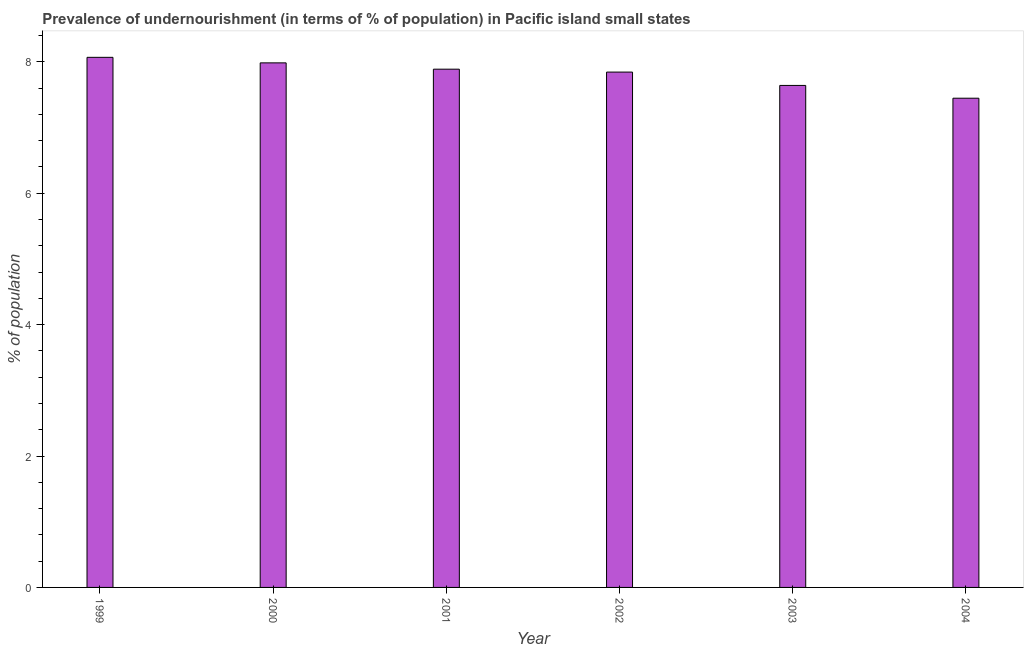Does the graph contain grids?
Your answer should be very brief. No. What is the title of the graph?
Your answer should be compact. Prevalence of undernourishment (in terms of % of population) in Pacific island small states. What is the label or title of the X-axis?
Your response must be concise. Year. What is the label or title of the Y-axis?
Keep it short and to the point. % of population. What is the percentage of undernourished population in 2004?
Offer a terse response. 7.45. Across all years, what is the maximum percentage of undernourished population?
Your response must be concise. 8.07. Across all years, what is the minimum percentage of undernourished population?
Give a very brief answer. 7.45. What is the sum of the percentage of undernourished population?
Your answer should be compact. 46.87. What is the difference between the percentage of undernourished population in 2002 and 2004?
Offer a very short reply. 0.4. What is the average percentage of undernourished population per year?
Provide a succinct answer. 7.81. What is the median percentage of undernourished population?
Your answer should be compact. 7.87. In how many years, is the percentage of undernourished population greater than 3.6 %?
Offer a terse response. 6. Do a majority of the years between 1999 and 2000 (inclusive) have percentage of undernourished population greater than 2.8 %?
Make the answer very short. Yes. Is the percentage of undernourished population in 1999 less than that in 2000?
Your answer should be compact. No. What is the difference between the highest and the second highest percentage of undernourished population?
Make the answer very short. 0.08. What is the difference between the highest and the lowest percentage of undernourished population?
Offer a very short reply. 0.62. How many bars are there?
Make the answer very short. 6. How many years are there in the graph?
Ensure brevity in your answer.  6. What is the difference between two consecutive major ticks on the Y-axis?
Your response must be concise. 2. What is the % of population of 1999?
Offer a terse response. 8.07. What is the % of population in 2000?
Provide a short and direct response. 7.98. What is the % of population in 2001?
Make the answer very short. 7.89. What is the % of population of 2002?
Your answer should be very brief. 7.84. What is the % of population of 2003?
Provide a succinct answer. 7.64. What is the % of population of 2004?
Provide a short and direct response. 7.45. What is the difference between the % of population in 1999 and 2000?
Offer a very short reply. 0.08. What is the difference between the % of population in 1999 and 2001?
Ensure brevity in your answer.  0.18. What is the difference between the % of population in 1999 and 2002?
Ensure brevity in your answer.  0.22. What is the difference between the % of population in 1999 and 2003?
Make the answer very short. 0.43. What is the difference between the % of population in 1999 and 2004?
Offer a terse response. 0.62. What is the difference between the % of population in 2000 and 2001?
Provide a succinct answer. 0.1. What is the difference between the % of population in 2000 and 2002?
Provide a short and direct response. 0.14. What is the difference between the % of population in 2000 and 2003?
Provide a short and direct response. 0.34. What is the difference between the % of population in 2000 and 2004?
Make the answer very short. 0.54. What is the difference between the % of population in 2001 and 2002?
Make the answer very short. 0.04. What is the difference between the % of population in 2001 and 2003?
Make the answer very short. 0.25. What is the difference between the % of population in 2001 and 2004?
Ensure brevity in your answer.  0.44. What is the difference between the % of population in 2002 and 2003?
Keep it short and to the point. 0.2. What is the difference between the % of population in 2002 and 2004?
Your answer should be very brief. 0.4. What is the difference between the % of population in 2003 and 2004?
Your answer should be very brief. 0.19. What is the ratio of the % of population in 1999 to that in 2001?
Provide a short and direct response. 1.02. What is the ratio of the % of population in 1999 to that in 2003?
Provide a succinct answer. 1.06. What is the ratio of the % of population in 1999 to that in 2004?
Your response must be concise. 1.08. What is the ratio of the % of population in 2000 to that in 2002?
Provide a succinct answer. 1.02. What is the ratio of the % of population in 2000 to that in 2003?
Your response must be concise. 1.04. What is the ratio of the % of population in 2000 to that in 2004?
Your response must be concise. 1.07. What is the ratio of the % of population in 2001 to that in 2003?
Your answer should be very brief. 1.03. What is the ratio of the % of population in 2001 to that in 2004?
Provide a succinct answer. 1.06. What is the ratio of the % of population in 2002 to that in 2003?
Make the answer very short. 1.03. What is the ratio of the % of population in 2002 to that in 2004?
Your answer should be compact. 1.05. 